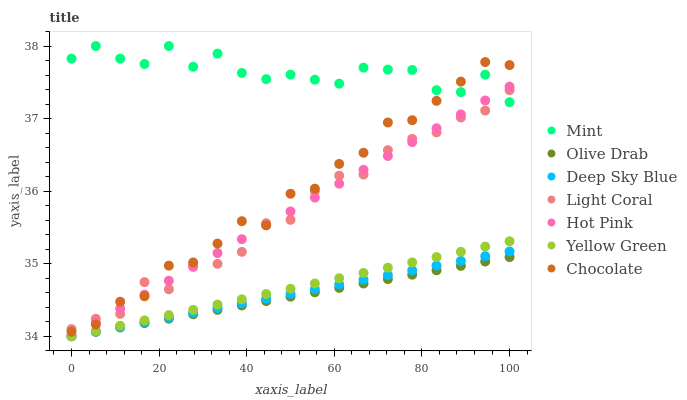Does Olive Drab have the minimum area under the curve?
Answer yes or no. Yes. Does Mint have the maximum area under the curve?
Answer yes or no. Yes. Does Hot Pink have the minimum area under the curve?
Answer yes or no. No. Does Hot Pink have the maximum area under the curve?
Answer yes or no. No. Is Deep Sky Blue the smoothest?
Answer yes or no. Yes. Is Mint the roughest?
Answer yes or no. Yes. Is Hot Pink the smoothest?
Answer yes or no. No. Is Hot Pink the roughest?
Answer yes or no. No. Does Yellow Green have the lowest value?
Answer yes or no. Yes. Does Chocolate have the lowest value?
Answer yes or no. No. Does Mint have the highest value?
Answer yes or no. Yes. Does Hot Pink have the highest value?
Answer yes or no. No. Is Olive Drab less than Mint?
Answer yes or no. Yes. Is Light Coral greater than Olive Drab?
Answer yes or no. Yes. Does Chocolate intersect Mint?
Answer yes or no. Yes. Is Chocolate less than Mint?
Answer yes or no. No. Is Chocolate greater than Mint?
Answer yes or no. No. Does Olive Drab intersect Mint?
Answer yes or no. No. 